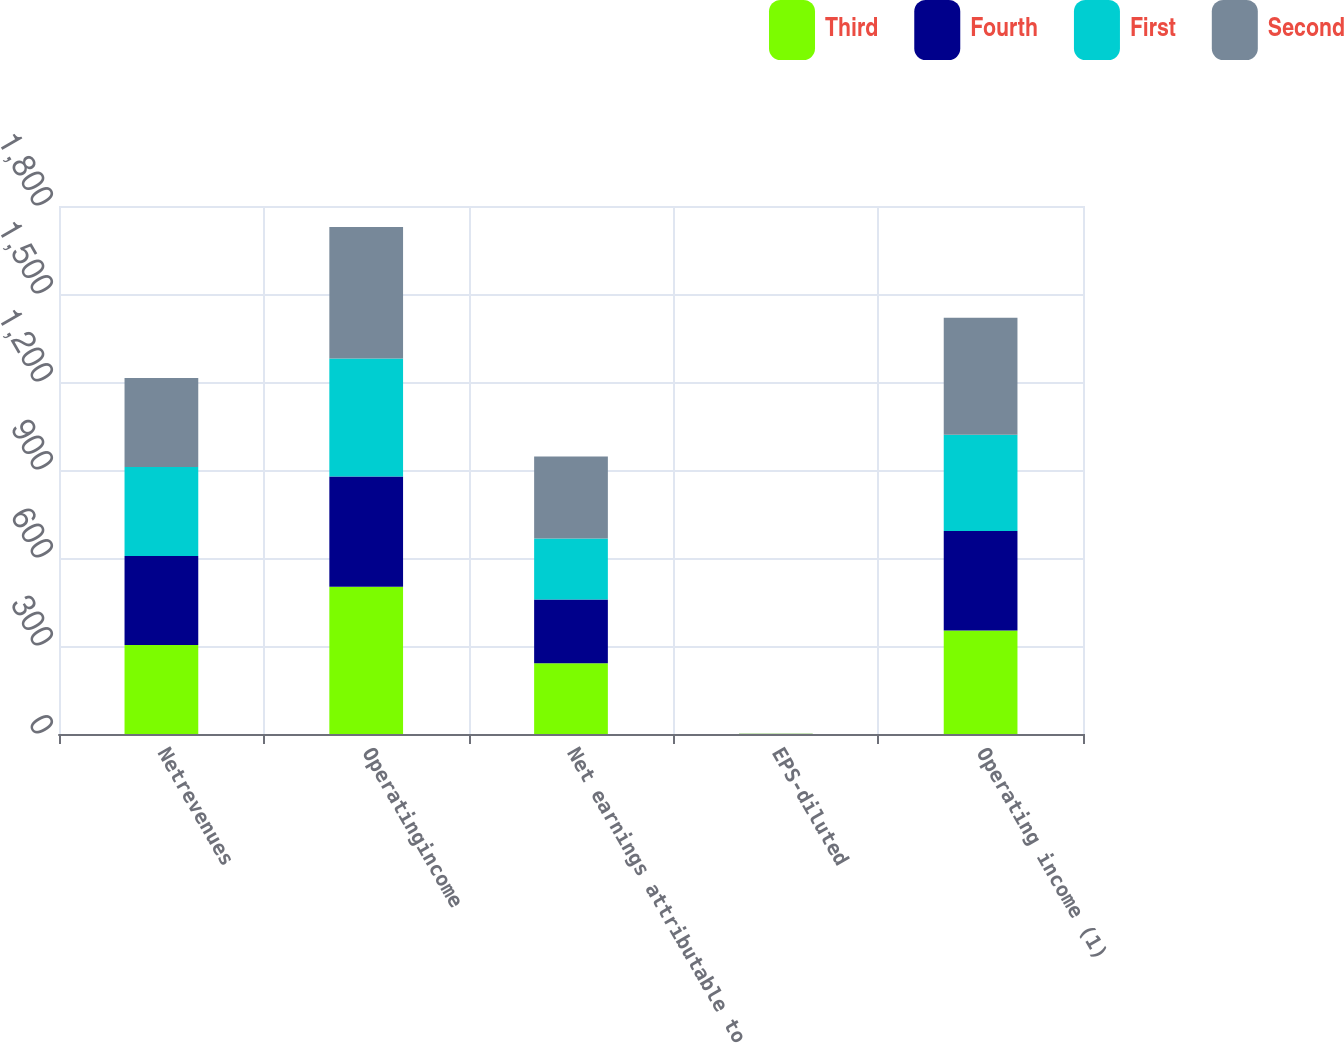Convert chart to OTSL. <chart><loc_0><loc_0><loc_500><loc_500><stacked_bar_chart><ecel><fcel>Netrevenues<fcel>Operatingincome<fcel>Net earnings attributable to<fcel>EPS-diluted<fcel>Operating income (1)<nl><fcel>Third<fcel>303.4<fcel>501.9<fcel>241.5<fcel>0.45<fcel>352.6<nl><fcel>Fourth<fcel>303.4<fcel>376.1<fcel>217.3<fcel>0.34<fcel>339.8<nl><fcel>First<fcel>303.4<fcel>402.2<fcel>207.9<fcel>0.36<fcel>327.7<nl><fcel>Second<fcel>303.4<fcel>448.3<fcel>278.9<fcel>0.47<fcel>399.3<nl></chart> 